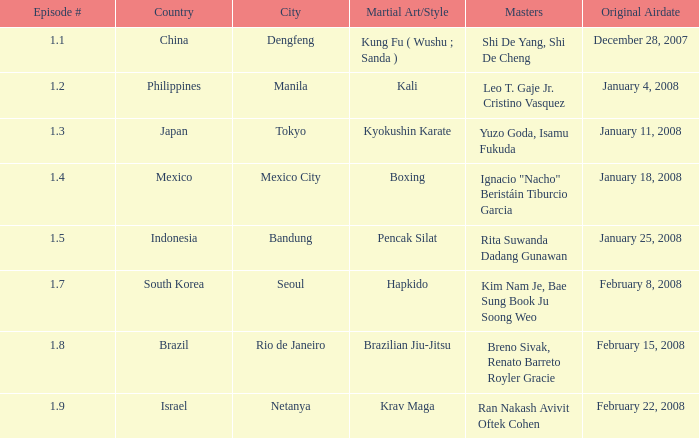How many times did episode 1.8 air? 1.0. 